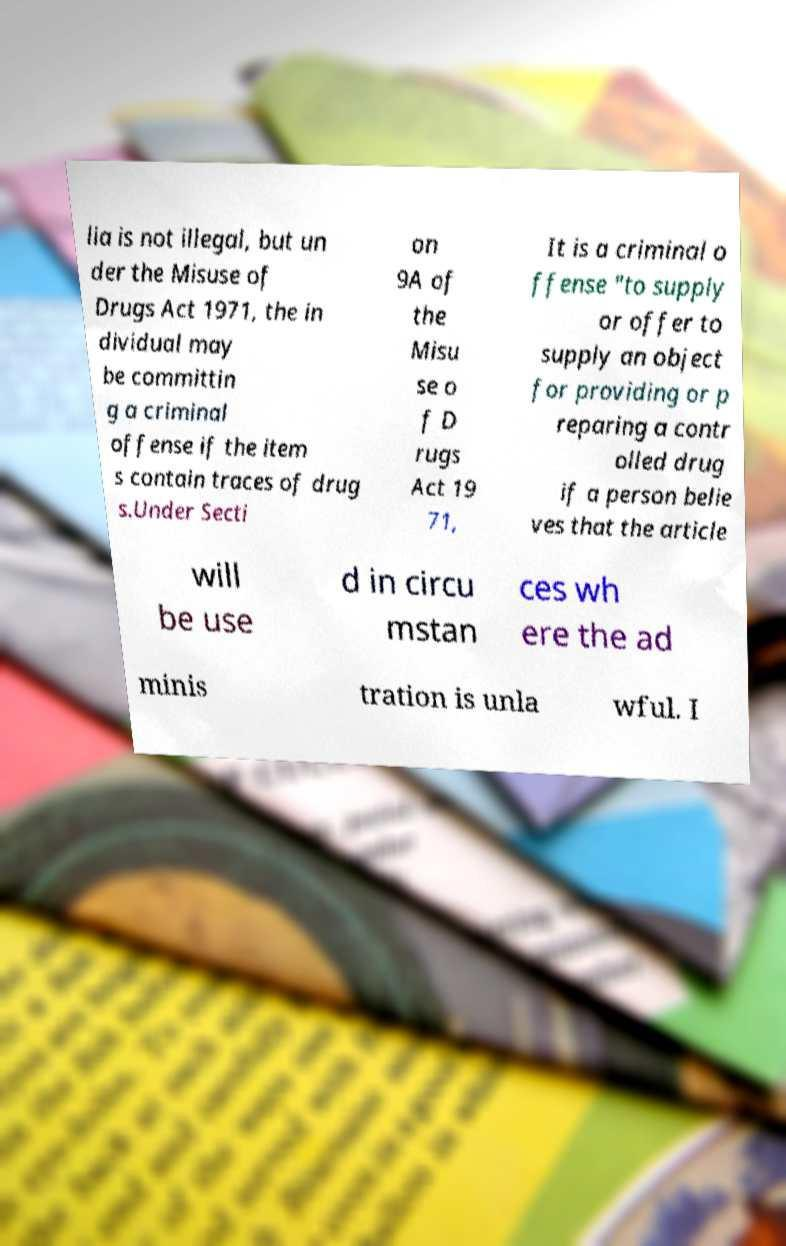Please read and relay the text visible in this image. What does it say? lia is not illegal, but un der the Misuse of Drugs Act 1971, the in dividual may be committin g a criminal offense if the item s contain traces of drug s.Under Secti on 9A of the Misu se o f D rugs Act 19 71, It is a criminal o ffense "to supply or offer to supply an object for providing or p reparing a contr olled drug if a person belie ves that the article will be use d in circu mstan ces wh ere the ad minis tration is unla wful. I 